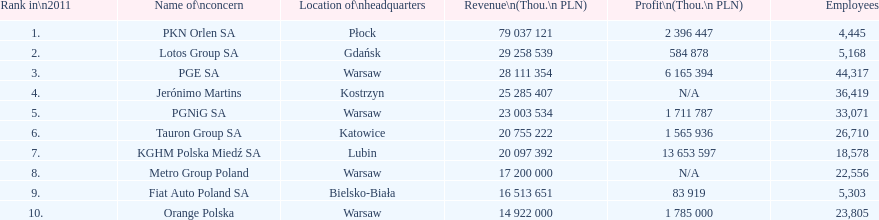Which corporation possesses the highest count of workers? PGE SA. 